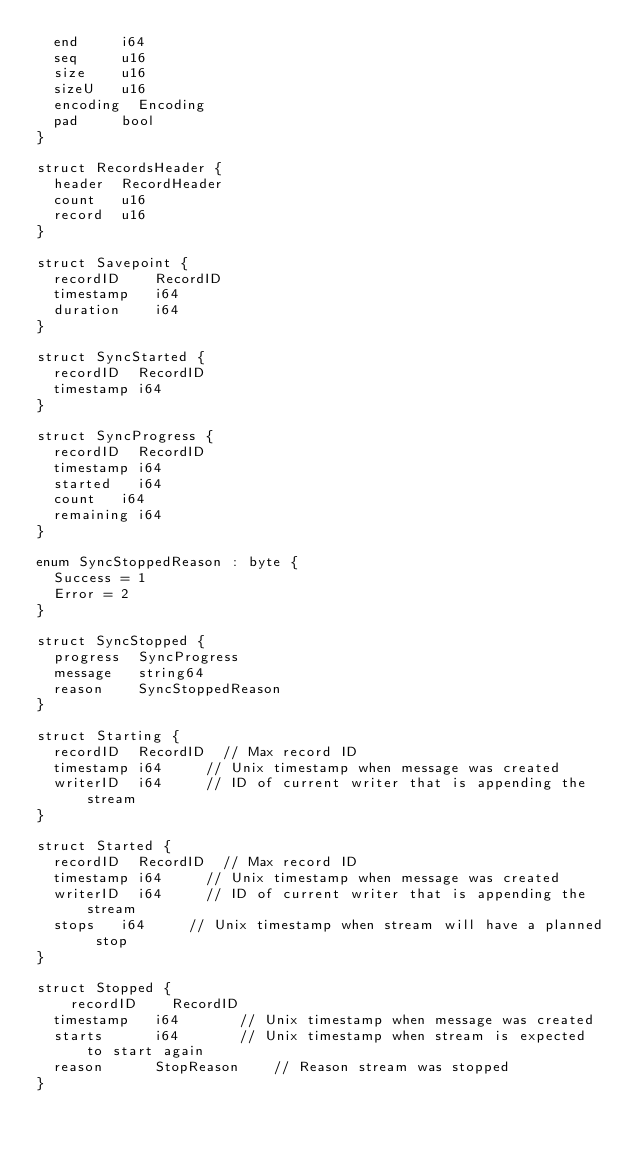<code> <loc_0><loc_0><loc_500><loc_500><_MoonScript_>	end			i64
	seq			u16
	size		u16
	sizeU		u16
	encoding	Encoding
	pad			bool
}

struct RecordsHeader {
	header 	RecordHeader
	count 	u16
	record 	u16
}

struct Savepoint {
	recordID		RecordID
	timestamp		i64
	duration		i64
}

struct SyncStarted {
	recordID	RecordID
	timestamp	i64
}

struct SyncProgress {
	recordID	RecordID
	timestamp	i64
	started		i64
	count		i64
	remaining	i64
}

enum SyncStoppedReason : byte {
	Success = 1
	Error = 2
}

struct SyncStopped {
	progress 	SyncProgress
	message		string64
	reason		SyncStoppedReason
}

struct Starting {
	recordID	RecordID	// Max record ID
	timestamp	i64			// Unix timestamp when message was created
	writerID	i64			// ID of current writer that is appending the stream
}

struct Started {
	recordID	RecordID	// Max record ID
	timestamp	i64			// Unix timestamp when message was created
	writerID	i64			// ID of current writer that is appending the stream
	stops		i64			// Unix timestamp when stream will have a planned stop
}

struct Stopped {
    recordID		RecordID
	timestamp		i64				// Unix timestamp when message was created
	starts			i64				// Unix timestamp when stream is expected to start again
	reason			StopReason		// Reason stream was stopped
}
</code> 